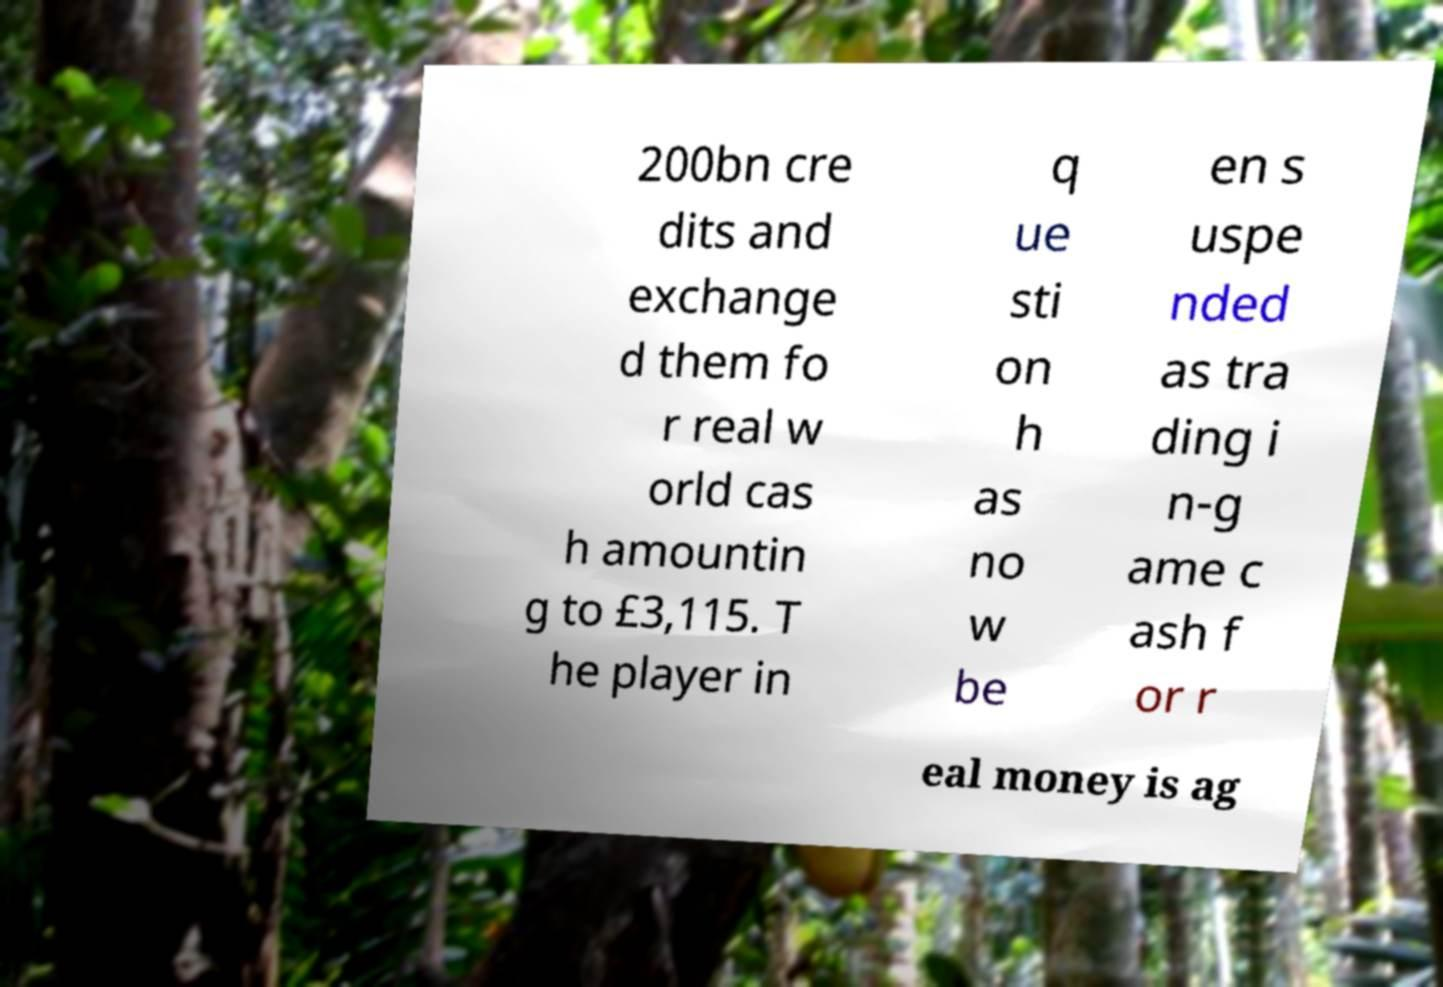There's text embedded in this image that I need extracted. Can you transcribe it verbatim? 200bn cre dits and exchange d them fo r real w orld cas h amountin g to £3,115. T he player in q ue sti on h as no w be en s uspe nded as tra ding i n-g ame c ash f or r eal money is ag 